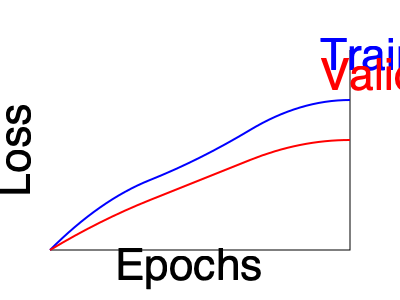Analyze the learning curves shown in the graph. What potential issue in the neural network training process does this graph indicate, and what technique could be applied to address it? To analyze the learning curves and identify the potential issue:

1. Observe the curves:
   - Blue curve represents training loss
   - Red curve represents validation loss

2. Notice the behavior of both curves:
   - Both curves are decreasing, indicating learning is occurring
   - Training loss (blue) is consistently lower than validation loss (red)
   - The gap between training and validation loss is widening as epochs increase

3. Identify the issue:
   - The widening gap between training and validation loss suggests overfitting
   - Overfitting occurs when the model learns the training data too well, including noise and peculiarities specific to the training set

4. Understand the implications:
   - An overfitted model performs well on training data but poorly on unseen data
   - This reduces the model's generalization capability

5. Consider techniques to address overfitting:
   - Regularization techniques (e.g., L1, L2 regularization)
   - Dropout
   - Early stopping
   - Increasing the training data size
   - Reducing model complexity

6. Select an appropriate technique:
   - Given the clear indication of overfitting, regularization would be a suitable choice
   - L2 regularization (weight decay) is a common and effective method

The L2 regularization technique adds a penalty term to the loss function:

$$ L_{new} = L_{original} + \lambda \sum_{w} w^2 $$

Where $L_{new}$ is the new loss function, $L_{original}$ is the original loss, $\lambda$ is the regularization parameter, and $w$ represents the model weights.

This technique encourages smaller weights, reducing the model's complexity and tendency to overfit.
Answer: Overfitting; apply L2 regularization 